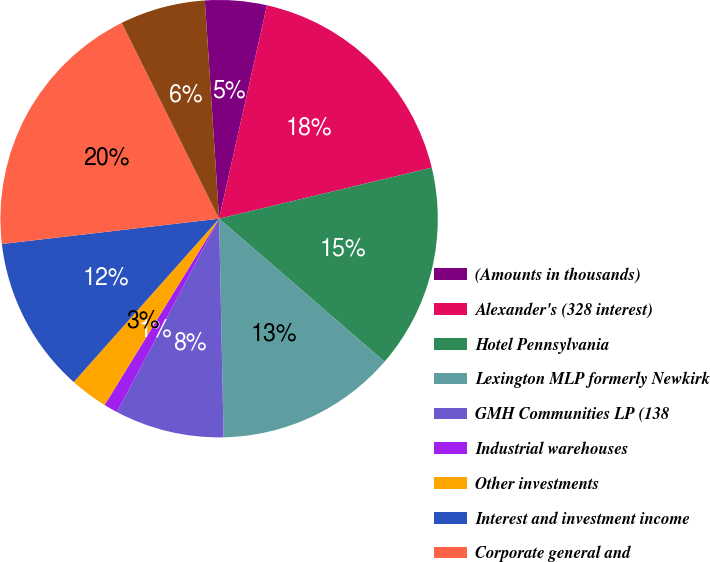Convert chart. <chart><loc_0><loc_0><loc_500><loc_500><pie_chart><fcel>(Amounts in thousands)<fcel>Alexander's (328 interest)<fcel>Hotel Pennsylvania<fcel>Lexington MLP formerly Newkirk<fcel>GMH Communities LP (138<fcel>Industrial warehouses<fcel>Other investments<fcel>Interest and investment income<fcel>Corporate general and<fcel>Minority limited partners'<nl><fcel>4.55%<fcel>17.74%<fcel>15.09%<fcel>13.33%<fcel>8.06%<fcel>1.04%<fcel>2.8%<fcel>11.58%<fcel>19.5%<fcel>6.31%<nl></chart> 